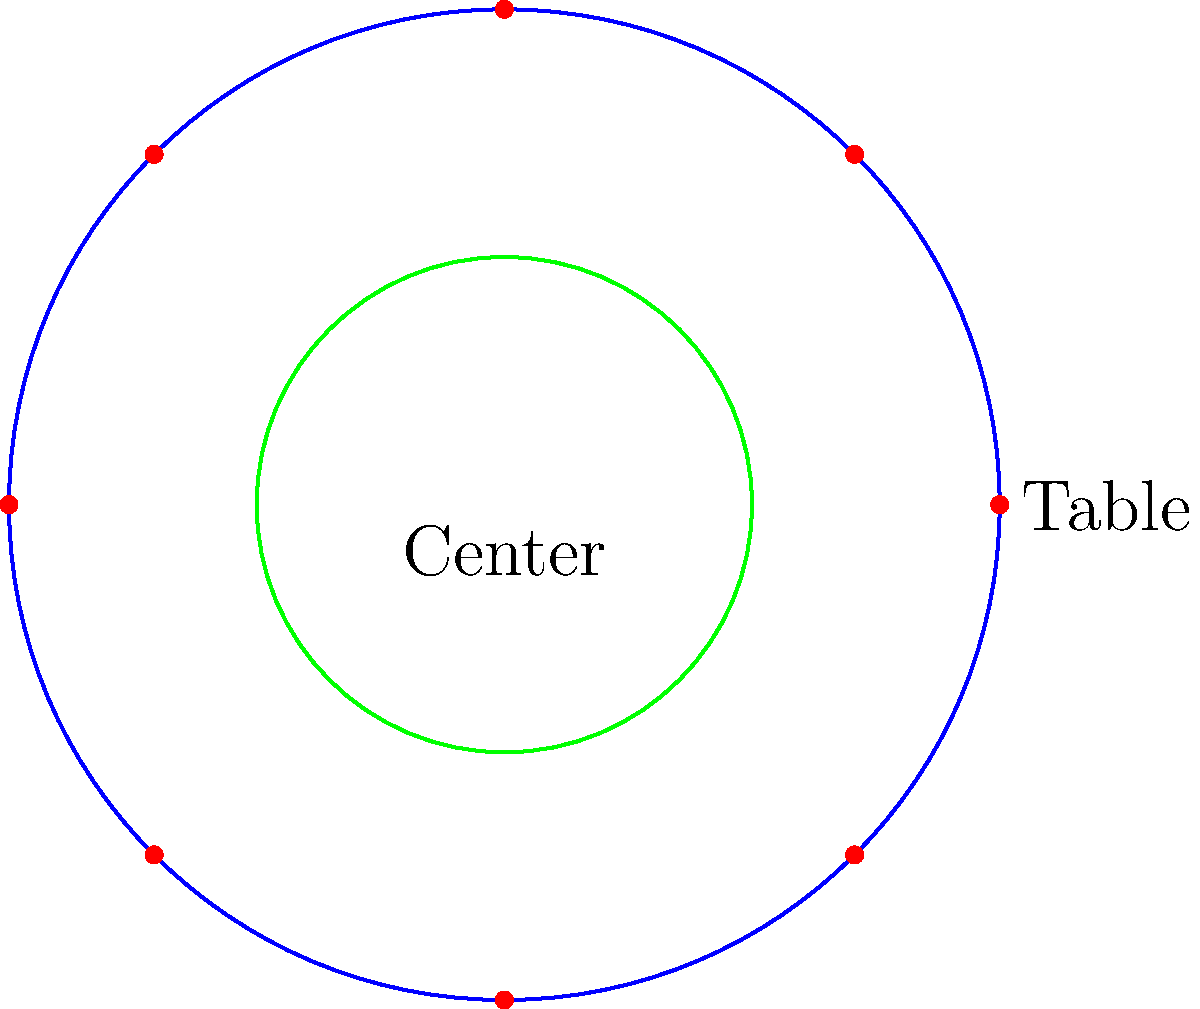You're setting up a circular party tent with a radius of 10 meters for a children's event. To maximize space efficiency, you decide to place 8 round tables along the tent's perimeter. If each table has a diameter of 2 meters, what is the distance $d$ (in meters) from the center of the tent to the center of each table, expressed in polar coordinates $(r, \theta)$? Let's approach this step-by-step:

1) The tent has a radius of 10 meters, and each table has a diameter of 2 meters (radius = 1 meter).

2) To maximize space, the tables should touch the tent's perimeter and be evenly spaced.

3) The distance $d$ we're looking for is slightly less than the tent's radius due to the table's size.

4) To calculate $d$, we need to subtract the table's radius from the tent's radius:
   $d = 10 - 1 = 9$ meters

5) For the angle $\theta$, we need to consider that there are 8 tables evenly spaced around the circle.
   A full circle is $2\pi$ radians, so each table is positioned at intervals of $\frac{2\pi}{8} = \frac{\pi}{4}$ radians.

6) The first table can be placed at $\theta = 0$, and subsequent tables will be at multiples of $\frac{\pi}{4}$.

7) Therefore, the polar coordinates for the tables are $(9, k\frac{\pi}{4})$, where $k = 0, 1, 2, ..., 7$.
Answer: $(9, k\frac{\pi}{4})$ meters, $k = 0, 1, 2, ..., 7$ 